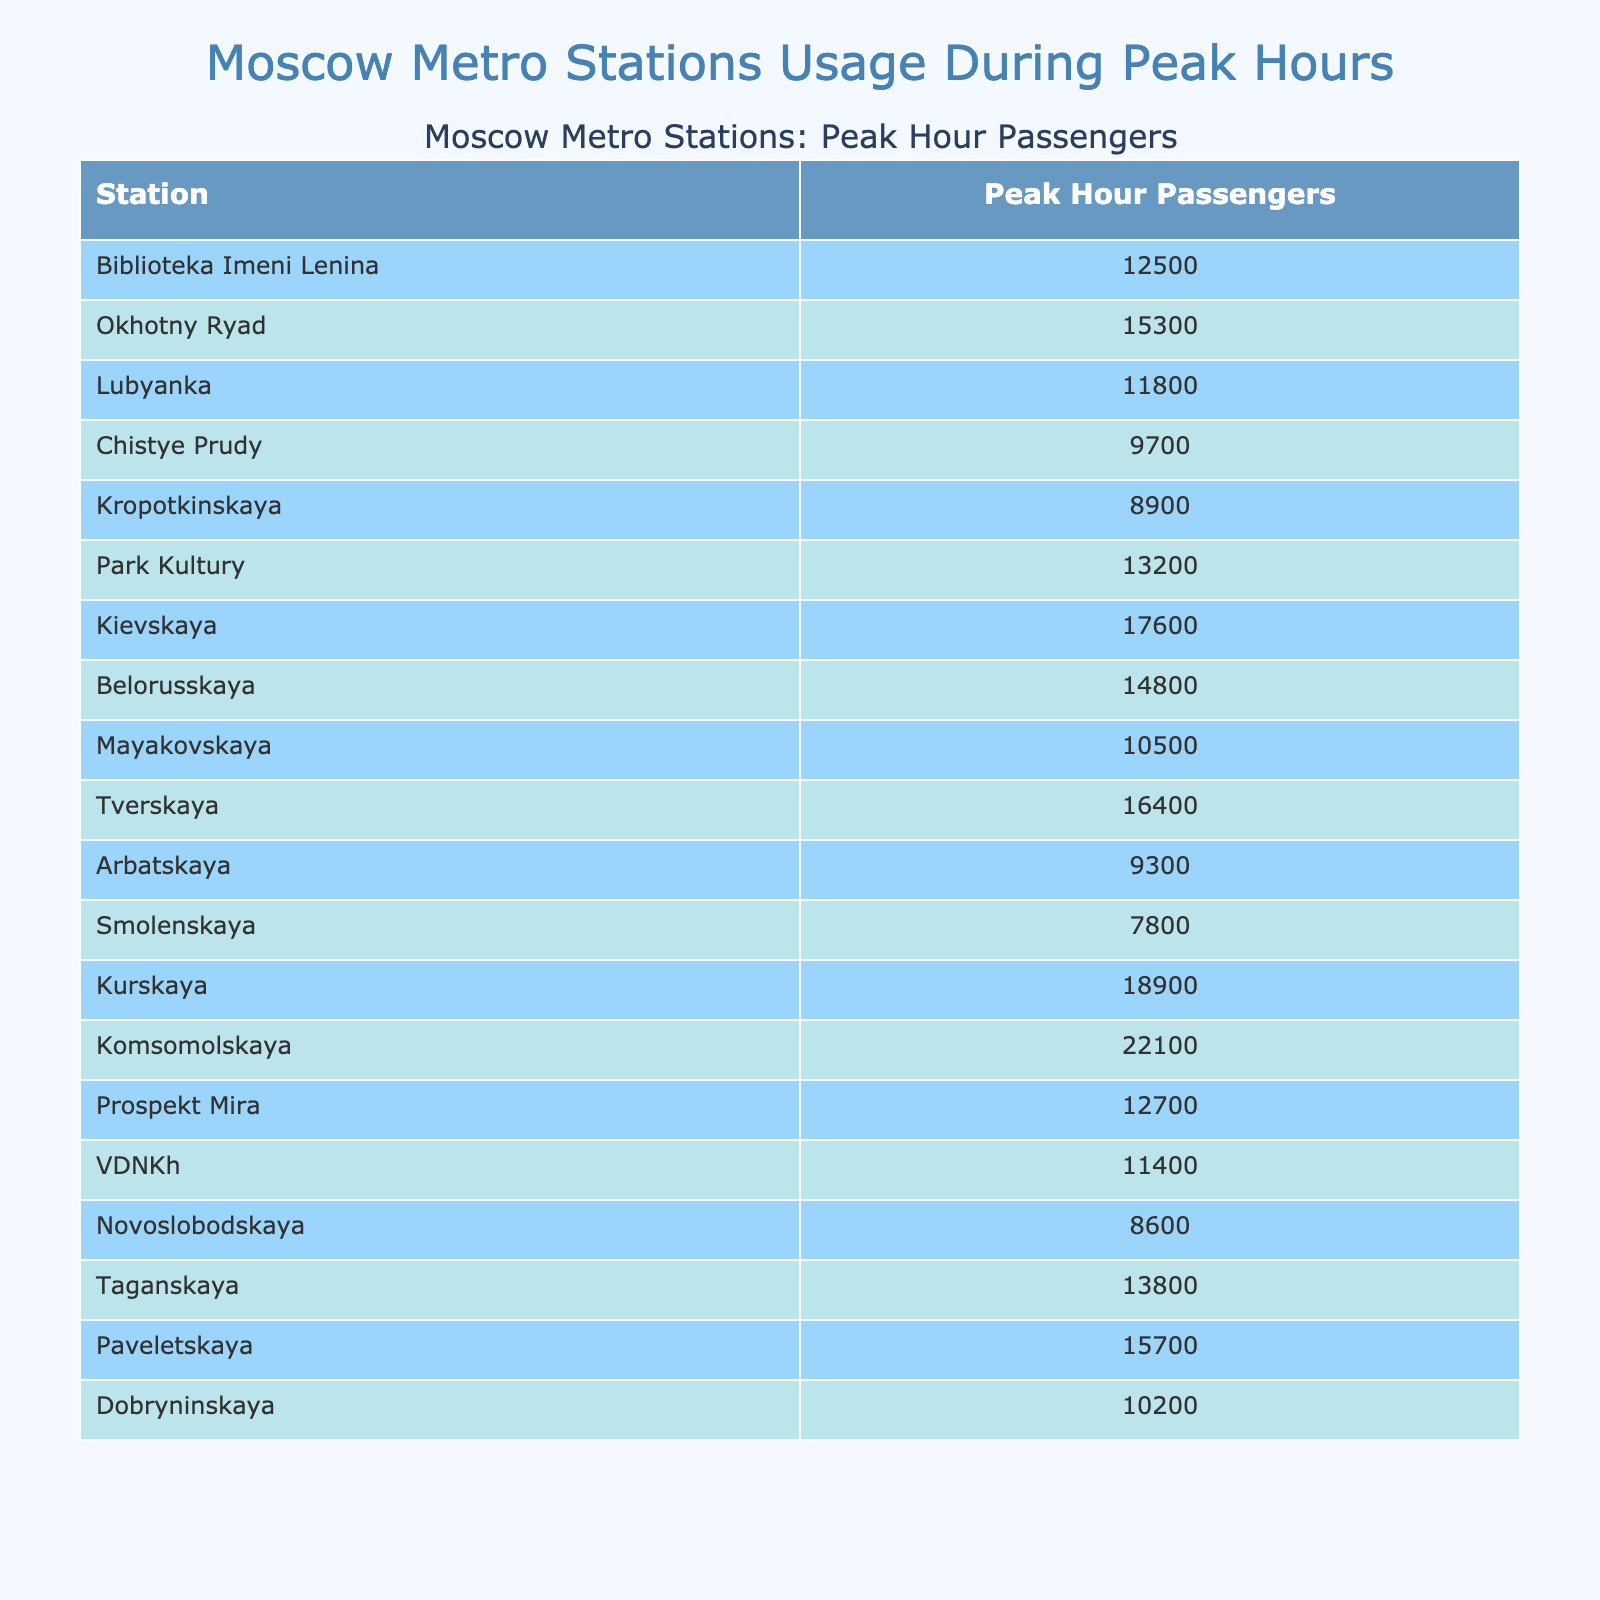What is the station with the highest passenger count during peak hours? By scanning the table, the station with the peak value is identified first. "Komsomolskaya" shows the highest figure of 22,100 passengers.
Answer: Komsomolskaya How many passengers use "Chistye Prudy" during peak hours? Looking at the table specifically for "Chistye Prudy", the passenger count is found to be 9,700.
Answer: 9700 What is the total number of passengers for "Park Kultury" and "Tverskaya"? To find this, add the number of passengers for both stations: 13,200 (Park Kultury) + 16,400 (Tverskaya) = 29,600.
Answer: 29600 Which station has fewer passengers: "Kropotkinskaya" or "Smolenskaya"? Checking the passenger counts, "Kropotkinskaya" has 8,900 while "Smolenskaya" has 7,800, indicating that Smolenskaya has fewer passengers.
Answer: Smolenskaya What is the average number of passengers across all stations listed? To find the average, sum all the passenger counts: 12500 + 15300 + 11800 + 9700 + 8900 + 13200 + 17600 + 14800 + 10500 + 16400 + 9300 + 7800 + 18900 + 22100 + 12700 + 11400 + 8600 + 13800 + 15700 + 10200 = 253700. There are 20 stations, so the average is 253700 / 20 = 12685.
Answer: 12685 Is the peak hour count for "Belorusskaya" more than the average peak hour count? We previously determined the average is 12,685, and "Belorusskaya" has 14,800 passengers, which is indeed more than the average: 14,800 > 12,685.
Answer: Yes What is the difference in peak hour passengers between "Kurskaya" and "Mayakovskaya"? The passenger counts show Kurskaya has 18,900 and Mayakovskaya 10,500, so the difference is 18,900 - 10,500 = 8,400.
Answer: 8400 How many stations have passenger counts above 15,000? Checking the table, the stations with counts exceeding 15,000 are: Okhotny Ryad, Kievskaya, Tverskaya, Komsomolskaya, and Paveletskaya. Counting these, there are 5 stations.
Answer: 5 Which station has exactly 12,700 passengers during peak hours? Referring to the table, "Prospekt Mira" has a count of 12,700 during peak hours.
Answer: Prospekt Mira What is the total number of passengers using the stations within the range of 10,000 to 15,000? Identify stations within this range: Lubyanka (11,800), Chistye Prudy (9,700), Kropotkinskaya (8,900), Park Kultury (13,200), Belorusskaya (14,800), Mayakovskaya (10,500), Prospekt Mira (12,700), Dobryninskaya (10,200). Adding these gives: 11800 + 13200 + 14800 + 10500 + 12700 + 10200 = 68,200.
Answer: 68200 What percentage of passengers at "Tverskaya" compared to "Komsomolskaya"? The passenger counts are Tverskaya (16,400) and Komsomolskaya (22,100). The percentage is calculated as (16,400 / 22,100) * 100, resulting in approximately 74.1%.
Answer: 74.1% 